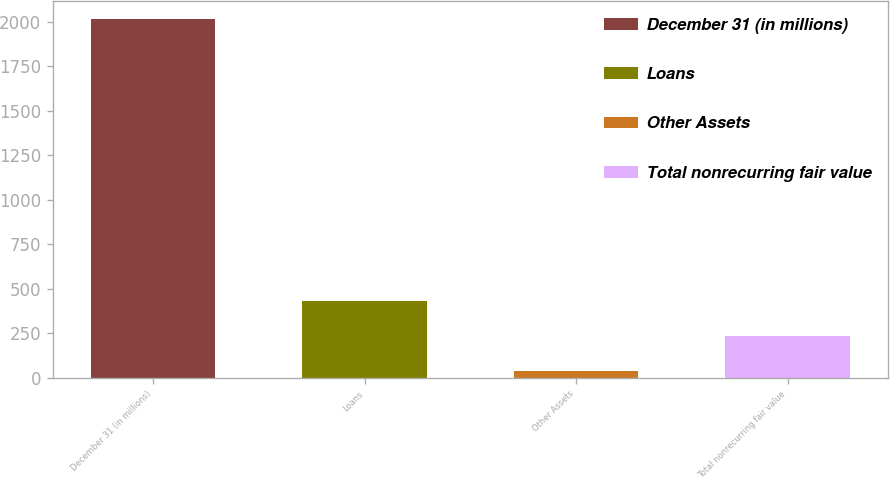Convert chart. <chart><loc_0><loc_0><loc_500><loc_500><bar_chart><fcel>December 31 (in millions)<fcel>Loans<fcel>Other Assets<fcel>Total nonrecurring fair value<nl><fcel>2016<fcel>432.8<fcel>37<fcel>234.9<nl></chart> 